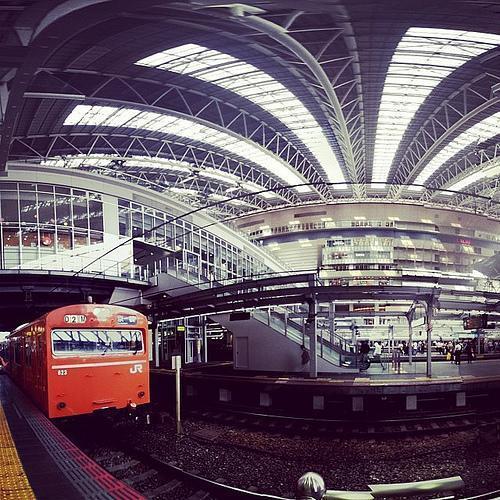How many of the skylight strips in the roof of the structure face toward the right?
Give a very brief answer. 3. 